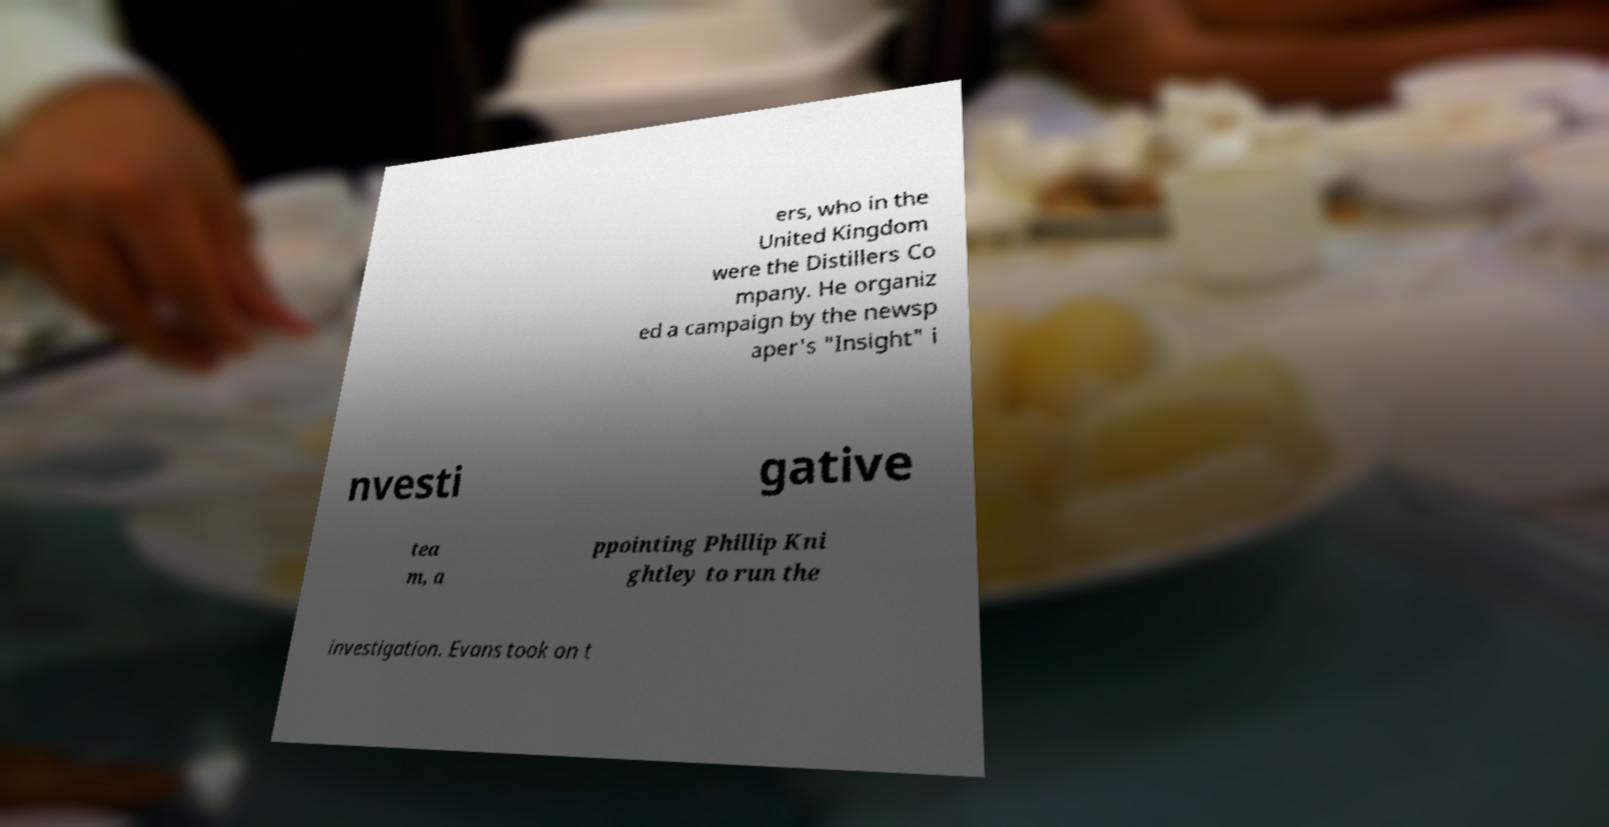There's text embedded in this image that I need extracted. Can you transcribe it verbatim? ers, who in the United Kingdom were the Distillers Co mpany. He organiz ed a campaign by the newsp aper's "Insight" i nvesti gative tea m, a ppointing Phillip Kni ghtley to run the investigation. Evans took on t 